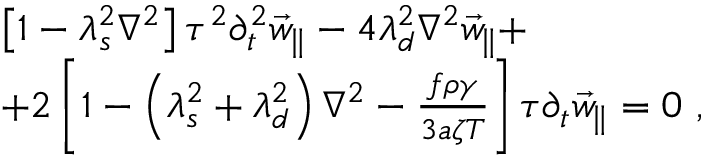<formula> <loc_0><loc_0><loc_500><loc_500>\begin{array} { r l } & { \left [ 1 - \lambda _ { s } ^ { 2 } \nabla ^ { 2 } \right ] \tau ^ { 2 } \partial _ { t } ^ { 2 } \vec { w } _ { \| } - 4 \lambda _ { d } ^ { 2 } \nabla ^ { 2 } \vec { w } _ { \| } + } \\ & { + 2 \left [ 1 - \left ( \lambda _ { s } ^ { 2 } + \lambda _ { d } ^ { 2 } \right ) \nabla ^ { 2 } - \frac { f \rho \gamma } { 3 a \zeta T } \right ] \tau \partial _ { t } \vec { w } _ { \| } = 0 \ , } \end{array}</formula> 